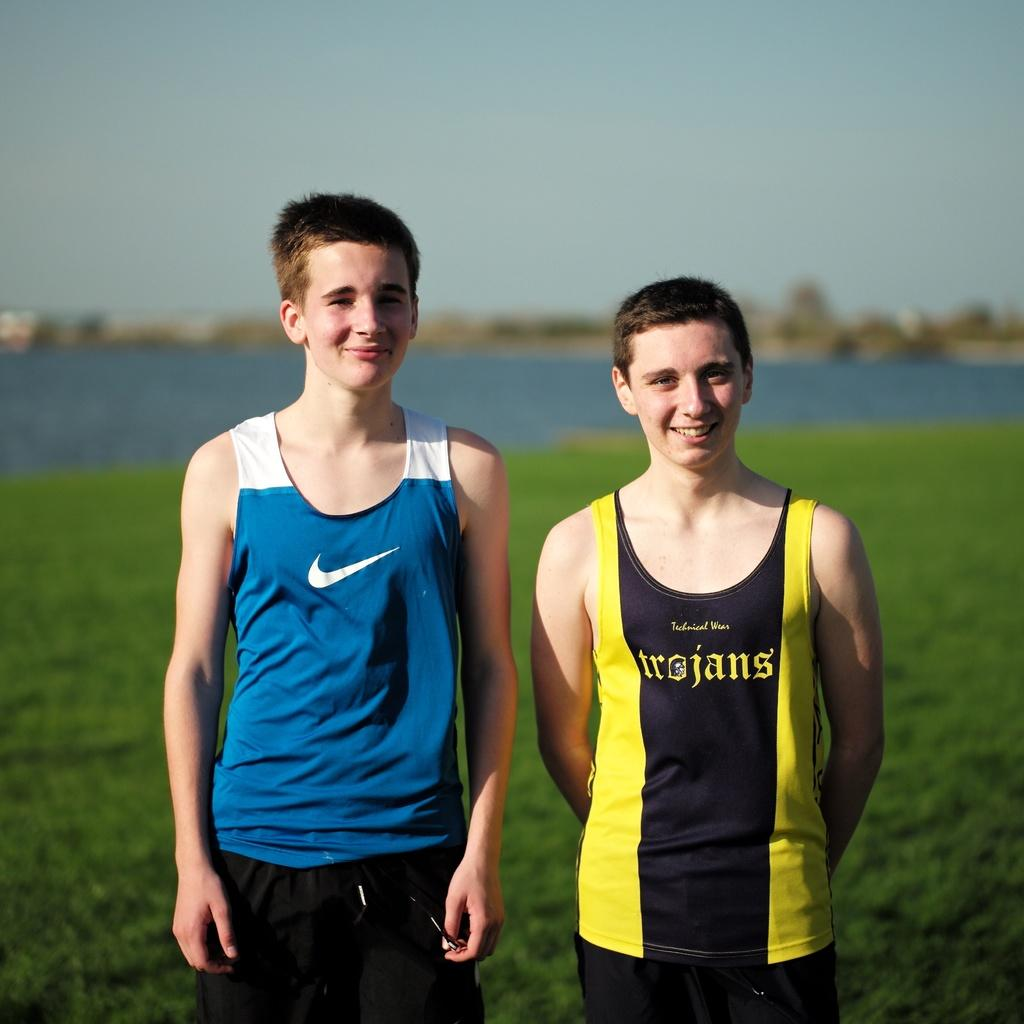<image>
Render a clear and concise summary of the photo. A boy wearing a yellow and black Trojans shirt. 